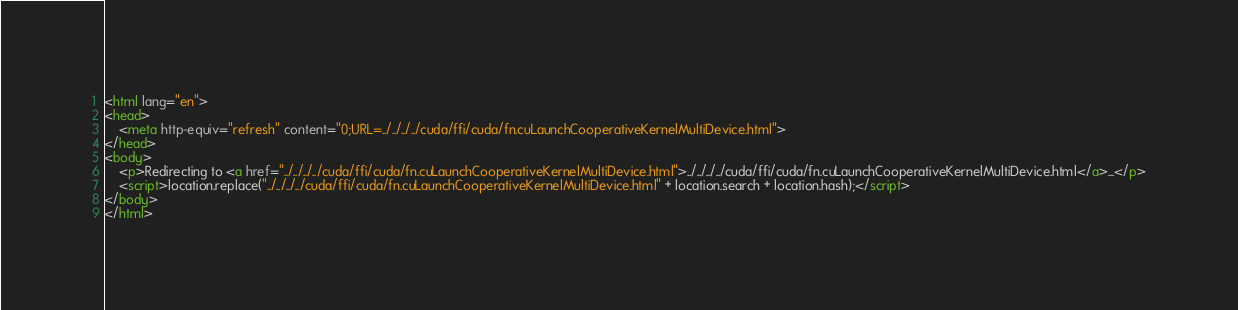Convert code to text. <code><loc_0><loc_0><loc_500><loc_500><_HTML_><html lang="en">
<head>
    <meta http-equiv="refresh" content="0;URL=../../../../cuda/ffi/cuda/fn.cuLaunchCooperativeKernelMultiDevice.html">
</head>
<body>
    <p>Redirecting to <a href="../../../../cuda/ffi/cuda/fn.cuLaunchCooperativeKernelMultiDevice.html">../../../../cuda/ffi/cuda/fn.cuLaunchCooperativeKernelMultiDevice.html</a>...</p>
    <script>location.replace("../../../../cuda/ffi/cuda/fn.cuLaunchCooperativeKernelMultiDevice.html" + location.search + location.hash);</script>
</body>
</html></code> 